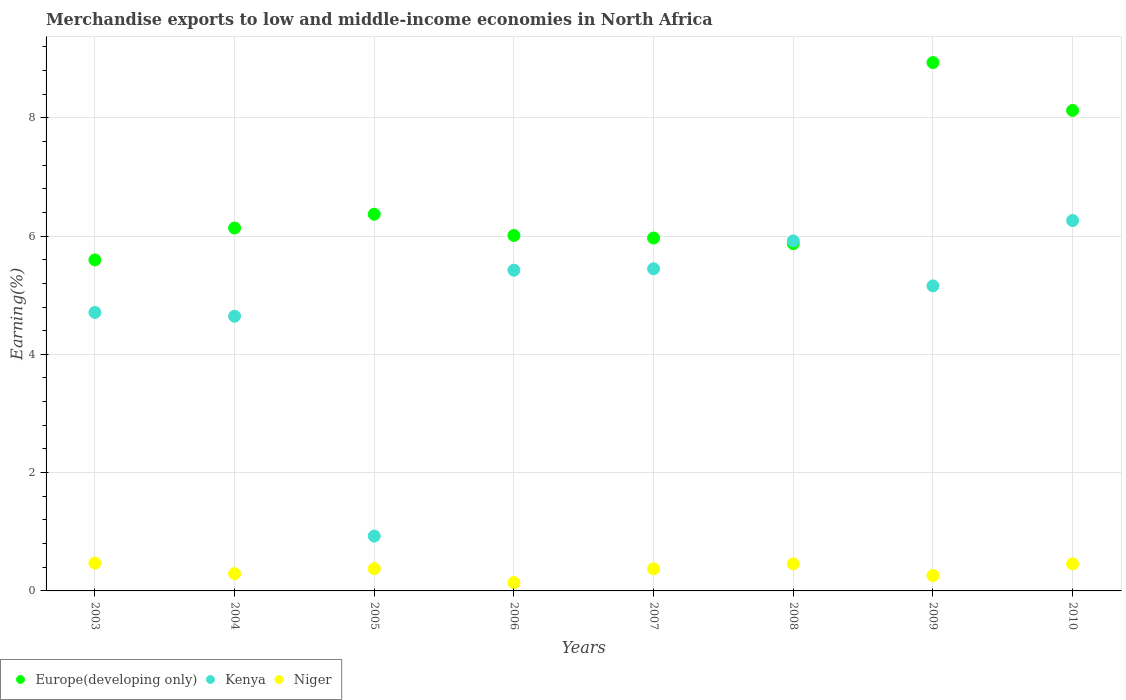How many different coloured dotlines are there?
Your response must be concise. 3. What is the percentage of amount earned from merchandise exports in Europe(developing only) in 2009?
Your answer should be compact. 8.93. Across all years, what is the maximum percentage of amount earned from merchandise exports in Europe(developing only)?
Offer a very short reply. 8.93. Across all years, what is the minimum percentage of amount earned from merchandise exports in Niger?
Give a very brief answer. 0.14. In which year was the percentage of amount earned from merchandise exports in Niger maximum?
Your answer should be very brief. 2003. What is the total percentage of amount earned from merchandise exports in Europe(developing only) in the graph?
Keep it short and to the point. 53. What is the difference between the percentage of amount earned from merchandise exports in Niger in 2006 and that in 2009?
Ensure brevity in your answer.  -0.12. What is the difference between the percentage of amount earned from merchandise exports in Europe(developing only) in 2005 and the percentage of amount earned from merchandise exports in Niger in 2007?
Give a very brief answer. 6. What is the average percentage of amount earned from merchandise exports in Niger per year?
Make the answer very short. 0.35. In the year 2007, what is the difference between the percentage of amount earned from merchandise exports in Niger and percentage of amount earned from merchandise exports in Kenya?
Provide a succinct answer. -5.07. What is the ratio of the percentage of amount earned from merchandise exports in Europe(developing only) in 2004 to that in 2010?
Ensure brevity in your answer.  0.76. Is the percentage of amount earned from merchandise exports in Kenya in 2007 less than that in 2010?
Give a very brief answer. Yes. Is the difference between the percentage of amount earned from merchandise exports in Niger in 2009 and 2010 greater than the difference between the percentage of amount earned from merchandise exports in Kenya in 2009 and 2010?
Offer a terse response. Yes. What is the difference between the highest and the second highest percentage of amount earned from merchandise exports in Niger?
Your answer should be compact. 0.01. What is the difference between the highest and the lowest percentage of amount earned from merchandise exports in Kenya?
Offer a terse response. 5.33. In how many years, is the percentage of amount earned from merchandise exports in Europe(developing only) greater than the average percentage of amount earned from merchandise exports in Europe(developing only) taken over all years?
Offer a terse response. 2. Is the sum of the percentage of amount earned from merchandise exports in Niger in 2003 and 2006 greater than the maximum percentage of amount earned from merchandise exports in Kenya across all years?
Provide a succinct answer. No. Does the percentage of amount earned from merchandise exports in Europe(developing only) monotonically increase over the years?
Your answer should be compact. No. Is the percentage of amount earned from merchandise exports in Kenya strictly less than the percentage of amount earned from merchandise exports in Niger over the years?
Your response must be concise. No. How many dotlines are there?
Your answer should be compact. 3. Does the graph contain grids?
Your answer should be very brief. Yes. Where does the legend appear in the graph?
Offer a terse response. Bottom left. How are the legend labels stacked?
Offer a very short reply. Horizontal. What is the title of the graph?
Offer a very short reply. Merchandise exports to low and middle-income economies in North Africa. What is the label or title of the X-axis?
Make the answer very short. Years. What is the label or title of the Y-axis?
Offer a terse response. Earning(%). What is the Earning(%) of Europe(developing only) in 2003?
Give a very brief answer. 5.6. What is the Earning(%) of Kenya in 2003?
Your response must be concise. 4.71. What is the Earning(%) of Niger in 2003?
Offer a very short reply. 0.47. What is the Earning(%) in Europe(developing only) in 2004?
Your response must be concise. 6.14. What is the Earning(%) of Kenya in 2004?
Provide a succinct answer. 4.64. What is the Earning(%) in Niger in 2004?
Make the answer very short. 0.29. What is the Earning(%) in Europe(developing only) in 2005?
Provide a short and direct response. 6.37. What is the Earning(%) in Kenya in 2005?
Offer a very short reply. 0.93. What is the Earning(%) of Niger in 2005?
Your answer should be compact. 0.38. What is the Earning(%) of Europe(developing only) in 2006?
Provide a short and direct response. 6.01. What is the Earning(%) of Kenya in 2006?
Your response must be concise. 5.42. What is the Earning(%) of Niger in 2006?
Provide a succinct answer. 0.14. What is the Earning(%) of Europe(developing only) in 2007?
Offer a very short reply. 5.97. What is the Earning(%) in Kenya in 2007?
Provide a succinct answer. 5.45. What is the Earning(%) of Niger in 2007?
Your answer should be compact. 0.37. What is the Earning(%) of Europe(developing only) in 2008?
Your response must be concise. 5.87. What is the Earning(%) of Kenya in 2008?
Your answer should be compact. 5.92. What is the Earning(%) in Niger in 2008?
Offer a terse response. 0.46. What is the Earning(%) of Europe(developing only) in 2009?
Your answer should be very brief. 8.93. What is the Earning(%) in Kenya in 2009?
Give a very brief answer. 5.16. What is the Earning(%) in Niger in 2009?
Ensure brevity in your answer.  0.26. What is the Earning(%) of Europe(developing only) in 2010?
Ensure brevity in your answer.  8.12. What is the Earning(%) of Kenya in 2010?
Provide a short and direct response. 6.26. What is the Earning(%) in Niger in 2010?
Your response must be concise. 0.46. Across all years, what is the maximum Earning(%) of Europe(developing only)?
Offer a terse response. 8.93. Across all years, what is the maximum Earning(%) in Kenya?
Your answer should be compact. 6.26. Across all years, what is the maximum Earning(%) in Niger?
Offer a very short reply. 0.47. Across all years, what is the minimum Earning(%) of Europe(developing only)?
Offer a very short reply. 5.6. Across all years, what is the minimum Earning(%) of Kenya?
Your answer should be compact. 0.93. Across all years, what is the minimum Earning(%) in Niger?
Offer a terse response. 0.14. What is the total Earning(%) in Europe(developing only) in the graph?
Offer a terse response. 53. What is the total Earning(%) of Kenya in the graph?
Your answer should be very brief. 38.49. What is the total Earning(%) in Niger in the graph?
Your answer should be compact. 2.83. What is the difference between the Earning(%) of Europe(developing only) in 2003 and that in 2004?
Provide a short and direct response. -0.54. What is the difference between the Earning(%) of Kenya in 2003 and that in 2004?
Give a very brief answer. 0.06. What is the difference between the Earning(%) of Niger in 2003 and that in 2004?
Make the answer very short. 0.18. What is the difference between the Earning(%) of Europe(developing only) in 2003 and that in 2005?
Offer a very short reply. -0.77. What is the difference between the Earning(%) of Kenya in 2003 and that in 2005?
Offer a terse response. 3.78. What is the difference between the Earning(%) of Niger in 2003 and that in 2005?
Ensure brevity in your answer.  0.1. What is the difference between the Earning(%) in Europe(developing only) in 2003 and that in 2006?
Ensure brevity in your answer.  -0.41. What is the difference between the Earning(%) of Kenya in 2003 and that in 2006?
Keep it short and to the point. -0.71. What is the difference between the Earning(%) in Niger in 2003 and that in 2006?
Your response must be concise. 0.33. What is the difference between the Earning(%) of Europe(developing only) in 2003 and that in 2007?
Provide a short and direct response. -0.37. What is the difference between the Earning(%) of Kenya in 2003 and that in 2007?
Ensure brevity in your answer.  -0.74. What is the difference between the Earning(%) in Niger in 2003 and that in 2007?
Your response must be concise. 0.1. What is the difference between the Earning(%) in Europe(developing only) in 2003 and that in 2008?
Provide a succinct answer. -0.28. What is the difference between the Earning(%) in Kenya in 2003 and that in 2008?
Give a very brief answer. -1.21. What is the difference between the Earning(%) in Niger in 2003 and that in 2008?
Provide a short and direct response. 0.01. What is the difference between the Earning(%) of Europe(developing only) in 2003 and that in 2009?
Provide a succinct answer. -3.34. What is the difference between the Earning(%) in Kenya in 2003 and that in 2009?
Keep it short and to the point. -0.45. What is the difference between the Earning(%) of Niger in 2003 and that in 2009?
Provide a short and direct response. 0.21. What is the difference between the Earning(%) in Europe(developing only) in 2003 and that in 2010?
Your answer should be compact. -2.53. What is the difference between the Earning(%) in Kenya in 2003 and that in 2010?
Offer a very short reply. -1.55. What is the difference between the Earning(%) of Niger in 2003 and that in 2010?
Offer a very short reply. 0.01. What is the difference between the Earning(%) of Europe(developing only) in 2004 and that in 2005?
Keep it short and to the point. -0.23. What is the difference between the Earning(%) of Kenya in 2004 and that in 2005?
Your response must be concise. 3.72. What is the difference between the Earning(%) of Niger in 2004 and that in 2005?
Offer a terse response. -0.08. What is the difference between the Earning(%) in Europe(developing only) in 2004 and that in 2006?
Provide a succinct answer. 0.13. What is the difference between the Earning(%) of Kenya in 2004 and that in 2006?
Give a very brief answer. -0.78. What is the difference between the Earning(%) of Niger in 2004 and that in 2006?
Provide a succinct answer. 0.15. What is the difference between the Earning(%) in Europe(developing only) in 2004 and that in 2007?
Offer a very short reply. 0.17. What is the difference between the Earning(%) of Kenya in 2004 and that in 2007?
Provide a succinct answer. -0.8. What is the difference between the Earning(%) of Niger in 2004 and that in 2007?
Your response must be concise. -0.08. What is the difference between the Earning(%) of Europe(developing only) in 2004 and that in 2008?
Offer a terse response. 0.26. What is the difference between the Earning(%) in Kenya in 2004 and that in 2008?
Your response must be concise. -1.27. What is the difference between the Earning(%) of Niger in 2004 and that in 2008?
Offer a very short reply. -0.17. What is the difference between the Earning(%) of Europe(developing only) in 2004 and that in 2009?
Provide a short and direct response. -2.8. What is the difference between the Earning(%) of Kenya in 2004 and that in 2009?
Ensure brevity in your answer.  -0.51. What is the difference between the Earning(%) of Niger in 2004 and that in 2009?
Keep it short and to the point. 0.03. What is the difference between the Earning(%) of Europe(developing only) in 2004 and that in 2010?
Keep it short and to the point. -1.99. What is the difference between the Earning(%) of Kenya in 2004 and that in 2010?
Your response must be concise. -1.62. What is the difference between the Earning(%) of Niger in 2004 and that in 2010?
Ensure brevity in your answer.  -0.17. What is the difference between the Earning(%) of Europe(developing only) in 2005 and that in 2006?
Your answer should be very brief. 0.36. What is the difference between the Earning(%) of Kenya in 2005 and that in 2006?
Your answer should be compact. -4.5. What is the difference between the Earning(%) in Niger in 2005 and that in 2006?
Your answer should be very brief. 0.24. What is the difference between the Earning(%) of Europe(developing only) in 2005 and that in 2007?
Offer a very short reply. 0.4. What is the difference between the Earning(%) in Kenya in 2005 and that in 2007?
Offer a very short reply. -4.52. What is the difference between the Earning(%) in Niger in 2005 and that in 2007?
Your response must be concise. 0. What is the difference between the Earning(%) of Europe(developing only) in 2005 and that in 2008?
Your answer should be compact. 0.5. What is the difference between the Earning(%) in Kenya in 2005 and that in 2008?
Give a very brief answer. -4.99. What is the difference between the Earning(%) of Niger in 2005 and that in 2008?
Your answer should be very brief. -0.08. What is the difference between the Earning(%) of Europe(developing only) in 2005 and that in 2009?
Make the answer very short. -2.56. What is the difference between the Earning(%) of Kenya in 2005 and that in 2009?
Your answer should be compact. -4.23. What is the difference between the Earning(%) in Niger in 2005 and that in 2009?
Keep it short and to the point. 0.12. What is the difference between the Earning(%) in Europe(developing only) in 2005 and that in 2010?
Make the answer very short. -1.75. What is the difference between the Earning(%) in Kenya in 2005 and that in 2010?
Provide a succinct answer. -5.33. What is the difference between the Earning(%) of Niger in 2005 and that in 2010?
Your answer should be compact. -0.08. What is the difference between the Earning(%) of Europe(developing only) in 2006 and that in 2007?
Give a very brief answer. 0.04. What is the difference between the Earning(%) in Kenya in 2006 and that in 2007?
Your answer should be very brief. -0.02. What is the difference between the Earning(%) in Niger in 2006 and that in 2007?
Your answer should be very brief. -0.23. What is the difference between the Earning(%) in Europe(developing only) in 2006 and that in 2008?
Offer a very short reply. 0.14. What is the difference between the Earning(%) in Kenya in 2006 and that in 2008?
Your answer should be compact. -0.5. What is the difference between the Earning(%) in Niger in 2006 and that in 2008?
Your answer should be very brief. -0.32. What is the difference between the Earning(%) in Europe(developing only) in 2006 and that in 2009?
Keep it short and to the point. -2.92. What is the difference between the Earning(%) in Kenya in 2006 and that in 2009?
Offer a terse response. 0.26. What is the difference between the Earning(%) of Niger in 2006 and that in 2009?
Offer a terse response. -0.12. What is the difference between the Earning(%) in Europe(developing only) in 2006 and that in 2010?
Your answer should be very brief. -2.11. What is the difference between the Earning(%) of Kenya in 2006 and that in 2010?
Make the answer very short. -0.84. What is the difference between the Earning(%) of Niger in 2006 and that in 2010?
Provide a succinct answer. -0.32. What is the difference between the Earning(%) of Europe(developing only) in 2007 and that in 2008?
Make the answer very short. 0.09. What is the difference between the Earning(%) in Kenya in 2007 and that in 2008?
Make the answer very short. -0.47. What is the difference between the Earning(%) in Niger in 2007 and that in 2008?
Your answer should be compact. -0.08. What is the difference between the Earning(%) of Europe(developing only) in 2007 and that in 2009?
Offer a very short reply. -2.97. What is the difference between the Earning(%) of Kenya in 2007 and that in 2009?
Give a very brief answer. 0.29. What is the difference between the Earning(%) of Niger in 2007 and that in 2009?
Keep it short and to the point. 0.11. What is the difference between the Earning(%) in Europe(developing only) in 2007 and that in 2010?
Offer a very short reply. -2.16. What is the difference between the Earning(%) of Kenya in 2007 and that in 2010?
Provide a succinct answer. -0.82. What is the difference between the Earning(%) in Niger in 2007 and that in 2010?
Provide a short and direct response. -0.08. What is the difference between the Earning(%) in Europe(developing only) in 2008 and that in 2009?
Your answer should be very brief. -3.06. What is the difference between the Earning(%) of Kenya in 2008 and that in 2009?
Keep it short and to the point. 0.76. What is the difference between the Earning(%) of Niger in 2008 and that in 2009?
Provide a short and direct response. 0.2. What is the difference between the Earning(%) in Europe(developing only) in 2008 and that in 2010?
Give a very brief answer. -2.25. What is the difference between the Earning(%) in Kenya in 2008 and that in 2010?
Your answer should be very brief. -0.34. What is the difference between the Earning(%) of Niger in 2008 and that in 2010?
Your answer should be compact. -0. What is the difference between the Earning(%) in Europe(developing only) in 2009 and that in 2010?
Your answer should be compact. 0.81. What is the difference between the Earning(%) of Kenya in 2009 and that in 2010?
Provide a succinct answer. -1.1. What is the difference between the Earning(%) in Niger in 2009 and that in 2010?
Your answer should be compact. -0.2. What is the difference between the Earning(%) of Europe(developing only) in 2003 and the Earning(%) of Kenya in 2004?
Offer a very short reply. 0.95. What is the difference between the Earning(%) in Europe(developing only) in 2003 and the Earning(%) in Niger in 2004?
Make the answer very short. 5.3. What is the difference between the Earning(%) in Kenya in 2003 and the Earning(%) in Niger in 2004?
Your answer should be compact. 4.42. What is the difference between the Earning(%) in Europe(developing only) in 2003 and the Earning(%) in Kenya in 2005?
Your answer should be compact. 4.67. What is the difference between the Earning(%) of Europe(developing only) in 2003 and the Earning(%) of Niger in 2005?
Offer a terse response. 5.22. What is the difference between the Earning(%) in Kenya in 2003 and the Earning(%) in Niger in 2005?
Provide a succinct answer. 4.33. What is the difference between the Earning(%) in Europe(developing only) in 2003 and the Earning(%) in Kenya in 2006?
Ensure brevity in your answer.  0.17. What is the difference between the Earning(%) of Europe(developing only) in 2003 and the Earning(%) of Niger in 2006?
Ensure brevity in your answer.  5.46. What is the difference between the Earning(%) of Kenya in 2003 and the Earning(%) of Niger in 2006?
Ensure brevity in your answer.  4.57. What is the difference between the Earning(%) of Europe(developing only) in 2003 and the Earning(%) of Kenya in 2007?
Provide a succinct answer. 0.15. What is the difference between the Earning(%) in Europe(developing only) in 2003 and the Earning(%) in Niger in 2007?
Your answer should be very brief. 5.22. What is the difference between the Earning(%) of Kenya in 2003 and the Earning(%) of Niger in 2007?
Your response must be concise. 4.33. What is the difference between the Earning(%) of Europe(developing only) in 2003 and the Earning(%) of Kenya in 2008?
Make the answer very short. -0.32. What is the difference between the Earning(%) in Europe(developing only) in 2003 and the Earning(%) in Niger in 2008?
Offer a terse response. 5.14. What is the difference between the Earning(%) of Kenya in 2003 and the Earning(%) of Niger in 2008?
Provide a succinct answer. 4.25. What is the difference between the Earning(%) of Europe(developing only) in 2003 and the Earning(%) of Kenya in 2009?
Give a very brief answer. 0.44. What is the difference between the Earning(%) of Europe(developing only) in 2003 and the Earning(%) of Niger in 2009?
Your answer should be compact. 5.34. What is the difference between the Earning(%) of Kenya in 2003 and the Earning(%) of Niger in 2009?
Provide a short and direct response. 4.45. What is the difference between the Earning(%) in Europe(developing only) in 2003 and the Earning(%) in Kenya in 2010?
Your response must be concise. -0.67. What is the difference between the Earning(%) in Europe(developing only) in 2003 and the Earning(%) in Niger in 2010?
Give a very brief answer. 5.14. What is the difference between the Earning(%) of Kenya in 2003 and the Earning(%) of Niger in 2010?
Ensure brevity in your answer.  4.25. What is the difference between the Earning(%) in Europe(developing only) in 2004 and the Earning(%) in Kenya in 2005?
Provide a short and direct response. 5.21. What is the difference between the Earning(%) of Europe(developing only) in 2004 and the Earning(%) of Niger in 2005?
Make the answer very short. 5.76. What is the difference between the Earning(%) in Kenya in 2004 and the Earning(%) in Niger in 2005?
Provide a short and direct response. 4.27. What is the difference between the Earning(%) of Europe(developing only) in 2004 and the Earning(%) of Kenya in 2006?
Your answer should be compact. 0.71. What is the difference between the Earning(%) in Europe(developing only) in 2004 and the Earning(%) in Niger in 2006?
Your answer should be very brief. 5.99. What is the difference between the Earning(%) of Kenya in 2004 and the Earning(%) of Niger in 2006?
Provide a short and direct response. 4.5. What is the difference between the Earning(%) of Europe(developing only) in 2004 and the Earning(%) of Kenya in 2007?
Provide a short and direct response. 0.69. What is the difference between the Earning(%) of Europe(developing only) in 2004 and the Earning(%) of Niger in 2007?
Provide a succinct answer. 5.76. What is the difference between the Earning(%) in Kenya in 2004 and the Earning(%) in Niger in 2007?
Offer a very short reply. 4.27. What is the difference between the Earning(%) of Europe(developing only) in 2004 and the Earning(%) of Kenya in 2008?
Offer a very short reply. 0.22. What is the difference between the Earning(%) of Europe(developing only) in 2004 and the Earning(%) of Niger in 2008?
Your response must be concise. 5.68. What is the difference between the Earning(%) in Kenya in 2004 and the Earning(%) in Niger in 2008?
Ensure brevity in your answer.  4.19. What is the difference between the Earning(%) of Europe(developing only) in 2004 and the Earning(%) of Kenya in 2009?
Keep it short and to the point. 0.98. What is the difference between the Earning(%) in Europe(developing only) in 2004 and the Earning(%) in Niger in 2009?
Provide a short and direct response. 5.87. What is the difference between the Earning(%) of Kenya in 2004 and the Earning(%) of Niger in 2009?
Give a very brief answer. 4.38. What is the difference between the Earning(%) of Europe(developing only) in 2004 and the Earning(%) of Kenya in 2010?
Give a very brief answer. -0.13. What is the difference between the Earning(%) of Europe(developing only) in 2004 and the Earning(%) of Niger in 2010?
Provide a short and direct response. 5.68. What is the difference between the Earning(%) in Kenya in 2004 and the Earning(%) in Niger in 2010?
Offer a very short reply. 4.19. What is the difference between the Earning(%) in Europe(developing only) in 2005 and the Earning(%) in Kenya in 2006?
Offer a very short reply. 0.95. What is the difference between the Earning(%) in Europe(developing only) in 2005 and the Earning(%) in Niger in 2006?
Your response must be concise. 6.23. What is the difference between the Earning(%) in Kenya in 2005 and the Earning(%) in Niger in 2006?
Your response must be concise. 0.79. What is the difference between the Earning(%) of Europe(developing only) in 2005 and the Earning(%) of Kenya in 2007?
Your answer should be very brief. 0.92. What is the difference between the Earning(%) in Europe(developing only) in 2005 and the Earning(%) in Niger in 2007?
Your response must be concise. 6. What is the difference between the Earning(%) in Kenya in 2005 and the Earning(%) in Niger in 2007?
Make the answer very short. 0.55. What is the difference between the Earning(%) in Europe(developing only) in 2005 and the Earning(%) in Kenya in 2008?
Provide a succinct answer. 0.45. What is the difference between the Earning(%) of Europe(developing only) in 2005 and the Earning(%) of Niger in 2008?
Your response must be concise. 5.91. What is the difference between the Earning(%) of Kenya in 2005 and the Earning(%) of Niger in 2008?
Keep it short and to the point. 0.47. What is the difference between the Earning(%) in Europe(developing only) in 2005 and the Earning(%) in Kenya in 2009?
Provide a short and direct response. 1.21. What is the difference between the Earning(%) of Europe(developing only) in 2005 and the Earning(%) of Niger in 2009?
Your response must be concise. 6.11. What is the difference between the Earning(%) of Kenya in 2005 and the Earning(%) of Niger in 2009?
Your answer should be very brief. 0.67. What is the difference between the Earning(%) of Europe(developing only) in 2005 and the Earning(%) of Kenya in 2010?
Keep it short and to the point. 0.11. What is the difference between the Earning(%) in Europe(developing only) in 2005 and the Earning(%) in Niger in 2010?
Ensure brevity in your answer.  5.91. What is the difference between the Earning(%) of Kenya in 2005 and the Earning(%) of Niger in 2010?
Make the answer very short. 0.47. What is the difference between the Earning(%) of Europe(developing only) in 2006 and the Earning(%) of Kenya in 2007?
Your answer should be compact. 0.56. What is the difference between the Earning(%) in Europe(developing only) in 2006 and the Earning(%) in Niger in 2007?
Ensure brevity in your answer.  5.64. What is the difference between the Earning(%) of Kenya in 2006 and the Earning(%) of Niger in 2007?
Offer a terse response. 5.05. What is the difference between the Earning(%) in Europe(developing only) in 2006 and the Earning(%) in Kenya in 2008?
Offer a very short reply. 0.09. What is the difference between the Earning(%) of Europe(developing only) in 2006 and the Earning(%) of Niger in 2008?
Provide a succinct answer. 5.55. What is the difference between the Earning(%) in Kenya in 2006 and the Earning(%) in Niger in 2008?
Keep it short and to the point. 4.97. What is the difference between the Earning(%) of Europe(developing only) in 2006 and the Earning(%) of Kenya in 2009?
Provide a short and direct response. 0.85. What is the difference between the Earning(%) of Europe(developing only) in 2006 and the Earning(%) of Niger in 2009?
Your answer should be compact. 5.75. What is the difference between the Earning(%) of Kenya in 2006 and the Earning(%) of Niger in 2009?
Make the answer very short. 5.16. What is the difference between the Earning(%) in Europe(developing only) in 2006 and the Earning(%) in Kenya in 2010?
Ensure brevity in your answer.  -0.25. What is the difference between the Earning(%) in Europe(developing only) in 2006 and the Earning(%) in Niger in 2010?
Provide a short and direct response. 5.55. What is the difference between the Earning(%) of Kenya in 2006 and the Earning(%) of Niger in 2010?
Provide a short and direct response. 4.96. What is the difference between the Earning(%) in Europe(developing only) in 2007 and the Earning(%) in Kenya in 2008?
Make the answer very short. 0.05. What is the difference between the Earning(%) of Europe(developing only) in 2007 and the Earning(%) of Niger in 2008?
Offer a terse response. 5.51. What is the difference between the Earning(%) of Kenya in 2007 and the Earning(%) of Niger in 2008?
Your answer should be very brief. 4.99. What is the difference between the Earning(%) in Europe(developing only) in 2007 and the Earning(%) in Kenya in 2009?
Offer a terse response. 0.81. What is the difference between the Earning(%) of Europe(developing only) in 2007 and the Earning(%) of Niger in 2009?
Offer a very short reply. 5.71. What is the difference between the Earning(%) in Kenya in 2007 and the Earning(%) in Niger in 2009?
Ensure brevity in your answer.  5.19. What is the difference between the Earning(%) in Europe(developing only) in 2007 and the Earning(%) in Kenya in 2010?
Ensure brevity in your answer.  -0.3. What is the difference between the Earning(%) in Europe(developing only) in 2007 and the Earning(%) in Niger in 2010?
Your answer should be very brief. 5.51. What is the difference between the Earning(%) of Kenya in 2007 and the Earning(%) of Niger in 2010?
Keep it short and to the point. 4.99. What is the difference between the Earning(%) of Europe(developing only) in 2008 and the Earning(%) of Kenya in 2009?
Offer a very short reply. 0.71. What is the difference between the Earning(%) in Europe(developing only) in 2008 and the Earning(%) in Niger in 2009?
Keep it short and to the point. 5.61. What is the difference between the Earning(%) of Kenya in 2008 and the Earning(%) of Niger in 2009?
Keep it short and to the point. 5.66. What is the difference between the Earning(%) of Europe(developing only) in 2008 and the Earning(%) of Kenya in 2010?
Ensure brevity in your answer.  -0.39. What is the difference between the Earning(%) in Europe(developing only) in 2008 and the Earning(%) in Niger in 2010?
Offer a terse response. 5.41. What is the difference between the Earning(%) of Kenya in 2008 and the Earning(%) of Niger in 2010?
Provide a succinct answer. 5.46. What is the difference between the Earning(%) of Europe(developing only) in 2009 and the Earning(%) of Kenya in 2010?
Offer a very short reply. 2.67. What is the difference between the Earning(%) in Europe(developing only) in 2009 and the Earning(%) in Niger in 2010?
Your response must be concise. 8.47. What is the difference between the Earning(%) of Kenya in 2009 and the Earning(%) of Niger in 2010?
Provide a short and direct response. 4.7. What is the average Earning(%) in Europe(developing only) per year?
Your answer should be very brief. 6.63. What is the average Earning(%) of Kenya per year?
Your answer should be very brief. 4.81. What is the average Earning(%) of Niger per year?
Keep it short and to the point. 0.35. In the year 2003, what is the difference between the Earning(%) of Europe(developing only) and Earning(%) of Kenya?
Offer a very short reply. 0.89. In the year 2003, what is the difference between the Earning(%) of Europe(developing only) and Earning(%) of Niger?
Your answer should be compact. 5.12. In the year 2003, what is the difference between the Earning(%) in Kenya and Earning(%) in Niger?
Provide a succinct answer. 4.24. In the year 2004, what is the difference between the Earning(%) in Europe(developing only) and Earning(%) in Kenya?
Give a very brief answer. 1.49. In the year 2004, what is the difference between the Earning(%) of Europe(developing only) and Earning(%) of Niger?
Provide a succinct answer. 5.84. In the year 2004, what is the difference between the Earning(%) of Kenya and Earning(%) of Niger?
Provide a succinct answer. 4.35. In the year 2005, what is the difference between the Earning(%) in Europe(developing only) and Earning(%) in Kenya?
Offer a terse response. 5.44. In the year 2005, what is the difference between the Earning(%) of Europe(developing only) and Earning(%) of Niger?
Provide a short and direct response. 5.99. In the year 2005, what is the difference between the Earning(%) in Kenya and Earning(%) in Niger?
Offer a terse response. 0.55. In the year 2006, what is the difference between the Earning(%) in Europe(developing only) and Earning(%) in Kenya?
Offer a very short reply. 0.59. In the year 2006, what is the difference between the Earning(%) of Europe(developing only) and Earning(%) of Niger?
Offer a terse response. 5.87. In the year 2006, what is the difference between the Earning(%) of Kenya and Earning(%) of Niger?
Offer a very short reply. 5.28. In the year 2007, what is the difference between the Earning(%) of Europe(developing only) and Earning(%) of Kenya?
Offer a very short reply. 0.52. In the year 2007, what is the difference between the Earning(%) of Europe(developing only) and Earning(%) of Niger?
Keep it short and to the point. 5.59. In the year 2007, what is the difference between the Earning(%) of Kenya and Earning(%) of Niger?
Your answer should be very brief. 5.07. In the year 2008, what is the difference between the Earning(%) in Europe(developing only) and Earning(%) in Kenya?
Offer a very short reply. -0.05. In the year 2008, what is the difference between the Earning(%) in Europe(developing only) and Earning(%) in Niger?
Provide a succinct answer. 5.41. In the year 2008, what is the difference between the Earning(%) of Kenya and Earning(%) of Niger?
Provide a succinct answer. 5.46. In the year 2009, what is the difference between the Earning(%) of Europe(developing only) and Earning(%) of Kenya?
Make the answer very short. 3.78. In the year 2009, what is the difference between the Earning(%) of Europe(developing only) and Earning(%) of Niger?
Make the answer very short. 8.67. In the year 2009, what is the difference between the Earning(%) of Kenya and Earning(%) of Niger?
Your response must be concise. 4.9. In the year 2010, what is the difference between the Earning(%) in Europe(developing only) and Earning(%) in Kenya?
Give a very brief answer. 1.86. In the year 2010, what is the difference between the Earning(%) of Europe(developing only) and Earning(%) of Niger?
Provide a succinct answer. 7.67. In the year 2010, what is the difference between the Earning(%) of Kenya and Earning(%) of Niger?
Ensure brevity in your answer.  5.8. What is the ratio of the Earning(%) in Europe(developing only) in 2003 to that in 2004?
Your response must be concise. 0.91. What is the ratio of the Earning(%) of Kenya in 2003 to that in 2004?
Provide a succinct answer. 1.01. What is the ratio of the Earning(%) of Niger in 2003 to that in 2004?
Give a very brief answer. 1.61. What is the ratio of the Earning(%) in Europe(developing only) in 2003 to that in 2005?
Ensure brevity in your answer.  0.88. What is the ratio of the Earning(%) of Kenya in 2003 to that in 2005?
Offer a very short reply. 5.08. What is the ratio of the Earning(%) in Niger in 2003 to that in 2005?
Your response must be concise. 1.25. What is the ratio of the Earning(%) in Europe(developing only) in 2003 to that in 2006?
Ensure brevity in your answer.  0.93. What is the ratio of the Earning(%) of Kenya in 2003 to that in 2006?
Offer a terse response. 0.87. What is the ratio of the Earning(%) in Niger in 2003 to that in 2006?
Your answer should be compact. 3.35. What is the ratio of the Earning(%) in Europe(developing only) in 2003 to that in 2007?
Give a very brief answer. 0.94. What is the ratio of the Earning(%) of Kenya in 2003 to that in 2007?
Your answer should be very brief. 0.86. What is the ratio of the Earning(%) of Niger in 2003 to that in 2007?
Provide a short and direct response. 1.26. What is the ratio of the Earning(%) in Europe(developing only) in 2003 to that in 2008?
Keep it short and to the point. 0.95. What is the ratio of the Earning(%) in Kenya in 2003 to that in 2008?
Offer a terse response. 0.8. What is the ratio of the Earning(%) of Niger in 2003 to that in 2008?
Offer a very short reply. 1.03. What is the ratio of the Earning(%) in Europe(developing only) in 2003 to that in 2009?
Offer a terse response. 0.63. What is the ratio of the Earning(%) in Kenya in 2003 to that in 2009?
Give a very brief answer. 0.91. What is the ratio of the Earning(%) of Niger in 2003 to that in 2009?
Your response must be concise. 1.81. What is the ratio of the Earning(%) in Europe(developing only) in 2003 to that in 2010?
Keep it short and to the point. 0.69. What is the ratio of the Earning(%) of Kenya in 2003 to that in 2010?
Keep it short and to the point. 0.75. What is the ratio of the Earning(%) in Niger in 2003 to that in 2010?
Your answer should be compact. 1.03. What is the ratio of the Earning(%) in Europe(developing only) in 2004 to that in 2005?
Give a very brief answer. 0.96. What is the ratio of the Earning(%) of Kenya in 2004 to that in 2005?
Keep it short and to the point. 5.01. What is the ratio of the Earning(%) in Niger in 2004 to that in 2005?
Offer a terse response. 0.78. What is the ratio of the Earning(%) of Europe(developing only) in 2004 to that in 2006?
Your response must be concise. 1.02. What is the ratio of the Earning(%) in Kenya in 2004 to that in 2006?
Offer a terse response. 0.86. What is the ratio of the Earning(%) in Niger in 2004 to that in 2006?
Offer a very short reply. 2.07. What is the ratio of the Earning(%) in Europe(developing only) in 2004 to that in 2007?
Make the answer very short. 1.03. What is the ratio of the Earning(%) in Kenya in 2004 to that in 2007?
Keep it short and to the point. 0.85. What is the ratio of the Earning(%) in Niger in 2004 to that in 2007?
Offer a terse response. 0.78. What is the ratio of the Earning(%) of Europe(developing only) in 2004 to that in 2008?
Make the answer very short. 1.04. What is the ratio of the Earning(%) in Kenya in 2004 to that in 2008?
Provide a short and direct response. 0.78. What is the ratio of the Earning(%) of Niger in 2004 to that in 2008?
Your answer should be compact. 0.64. What is the ratio of the Earning(%) of Europe(developing only) in 2004 to that in 2009?
Your answer should be very brief. 0.69. What is the ratio of the Earning(%) in Kenya in 2004 to that in 2009?
Give a very brief answer. 0.9. What is the ratio of the Earning(%) of Niger in 2004 to that in 2009?
Provide a short and direct response. 1.12. What is the ratio of the Earning(%) of Europe(developing only) in 2004 to that in 2010?
Provide a short and direct response. 0.76. What is the ratio of the Earning(%) in Kenya in 2004 to that in 2010?
Ensure brevity in your answer.  0.74. What is the ratio of the Earning(%) of Niger in 2004 to that in 2010?
Your answer should be very brief. 0.64. What is the ratio of the Earning(%) in Europe(developing only) in 2005 to that in 2006?
Ensure brevity in your answer.  1.06. What is the ratio of the Earning(%) in Kenya in 2005 to that in 2006?
Ensure brevity in your answer.  0.17. What is the ratio of the Earning(%) in Niger in 2005 to that in 2006?
Your answer should be compact. 2.67. What is the ratio of the Earning(%) in Europe(developing only) in 2005 to that in 2007?
Keep it short and to the point. 1.07. What is the ratio of the Earning(%) in Kenya in 2005 to that in 2007?
Provide a short and direct response. 0.17. What is the ratio of the Earning(%) of Niger in 2005 to that in 2007?
Make the answer very short. 1.01. What is the ratio of the Earning(%) in Europe(developing only) in 2005 to that in 2008?
Provide a short and direct response. 1.08. What is the ratio of the Earning(%) of Kenya in 2005 to that in 2008?
Your answer should be compact. 0.16. What is the ratio of the Earning(%) in Niger in 2005 to that in 2008?
Your response must be concise. 0.82. What is the ratio of the Earning(%) of Europe(developing only) in 2005 to that in 2009?
Keep it short and to the point. 0.71. What is the ratio of the Earning(%) of Kenya in 2005 to that in 2009?
Offer a terse response. 0.18. What is the ratio of the Earning(%) in Niger in 2005 to that in 2009?
Offer a terse response. 1.44. What is the ratio of the Earning(%) of Europe(developing only) in 2005 to that in 2010?
Offer a terse response. 0.78. What is the ratio of the Earning(%) of Kenya in 2005 to that in 2010?
Provide a short and direct response. 0.15. What is the ratio of the Earning(%) in Niger in 2005 to that in 2010?
Provide a succinct answer. 0.82. What is the ratio of the Earning(%) of Europe(developing only) in 2006 to that in 2007?
Provide a short and direct response. 1.01. What is the ratio of the Earning(%) in Kenya in 2006 to that in 2007?
Keep it short and to the point. 1. What is the ratio of the Earning(%) of Niger in 2006 to that in 2007?
Offer a very short reply. 0.38. What is the ratio of the Earning(%) in Europe(developing only) in 2006 to that in 2008?
Offer a terse response. 1.02. What is the ratio of the Earning(%) in Kenya in 2006 to that in 2008?
Offer a very short reply. 0.92. What is the ratio of the Earning(%) of Niger in 2006 to that in 2008?
Your answer should be compact. 0.31. What is the ratio of the Earning(%) of Europe(developing only) in 2006 to that in 2009?
Provide a short and direct response. 0.67. What is the ratio of the Earning(%) in Kenya in 2006 to that in 2009?
Offer a terse response. 1.05. What is the ratio of the Earning(%) in Niger in 2006 to that in 2009?
Provide a short and direct response. 0.54. What is the ratio of the Earning(%) in Europe(developing only) in 2006 to that in 2010?
Offer a terse response. 0.74. What is the ratio of the Earning(%) of Kenya in 2006 to that in 2010?
Your response must be concise. 0.87. What is the ratio of the Earning(%) in Niger in 2006 to that in 2010?
Your answer should be compact. 0.31. What is the ratio of the Earning(%) in Europe(developing only) in 2007 to that in 2008?
Provide a short and direct response. 1.02. What is the ratio of the Earning(%) of Kenya in 2007 to that in 2008?
Ensure brevity in your answer.  0.92. What is the ratio of the Earning(%) in Niger in 2007 to that in 2008?
Give a very brief answer. 0.82. What is the ratio of the Earning(%) of Europe(developing only) in 2007 to that in 2009?
Offer a very short reply. 0.67. What is the ratio of the Earning(%) in Kenya in 2007 to that in 2009?
Provide a short and direct response. 1.06. What is the ratio of the Earning(%) in Niger in 2007 to that in 2009?
Keep it short and to the point. 1.43. What is the ratio of the Earning(%) of Europe(developing only) in 2007 to that in 2010?
Offer a very short reply. 0.73. What is the ratio of the Earning(%) in Kenya in 2007 to that in 2010?
Ensure brevity in your answer.  0.87. What is the ratio of the Earning(%) of Niger in 2007 to that in 2010?
Ensure brevity in your answer.  0.81. What is the ratio of the Earning(%) in Europe(developing only) in 2008 to that in 2009?
Provide a succinct answer. 0.66. What is the ratio of the Earning(%) in Kenya in 2008 to that in 2009?
Make the answer very short. 1.15. What is the ratio of the Earning(%) in Niger in 2008 to that in 2009?
Offer a very short reply. 1.75. What is the ratio of the Earning(%) in Europe(developing only) in 2008 to that in 2010?
Your answer should be compact. 0.72. What is the ratio of the Earning(%) in Kenya in 2008 to that in 2010?
Provide a short and direct response. 0.95. What is the ratio of the Earning(%) of Europe(developing only) in 2009 to that in 2010?
Provide a short and direct response. 1.1. What is the ratio of the Earning(%) of Kenya in 2009 to that in 2010?
Your answer should be compact. 0.82. What is the ratio of the Earning(%) of Niger in 2009 to that in 2010?
Your answer should be compact. 0.57. What is the difference between the highest and the second highest Earning(%) in Europe(developing only)?
Ensure brevity in your answer.  0.81. What is the difference between the highest and the second highest Earning(%) of Kenya?
Offer a very short reply. 0.34. What is the difference between the highest and the second highest Earning(%) in Niger?
Give a very brief answer. 0.01. What is the difference between the highest and the lowest Earning(%) of Europe(developing only)?
Provide a succinct answer. 3.34. What is the difference between the highest and the lowest Earning(%) of Kenya?
Keep it short and to the point. 5.33. What is the difference between the highest and the lowest Earning(%) of Niger?
Offer a very short reply. 0.33. 